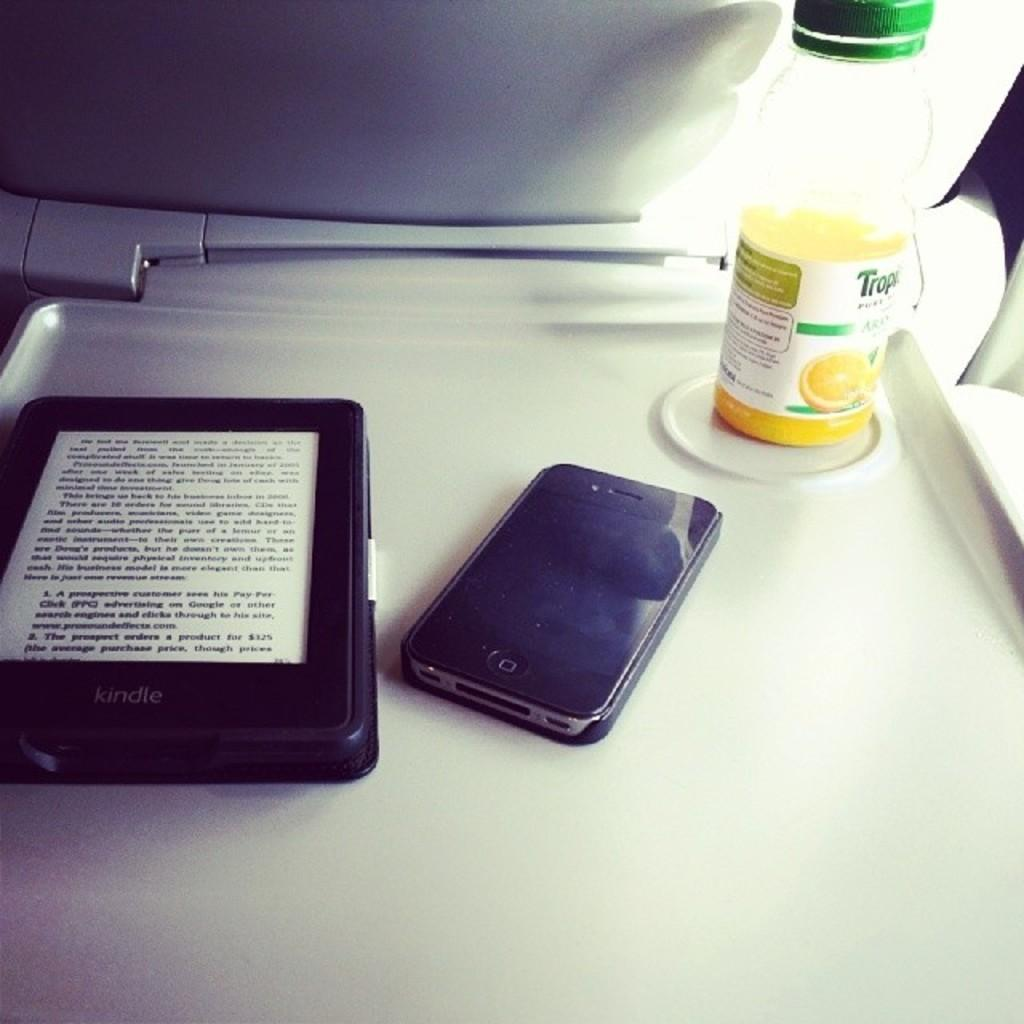<image>
Present a compact description of the photo's key features. A bottle of Tropicana juice on a tray along with an Iphone and a Kindle. 